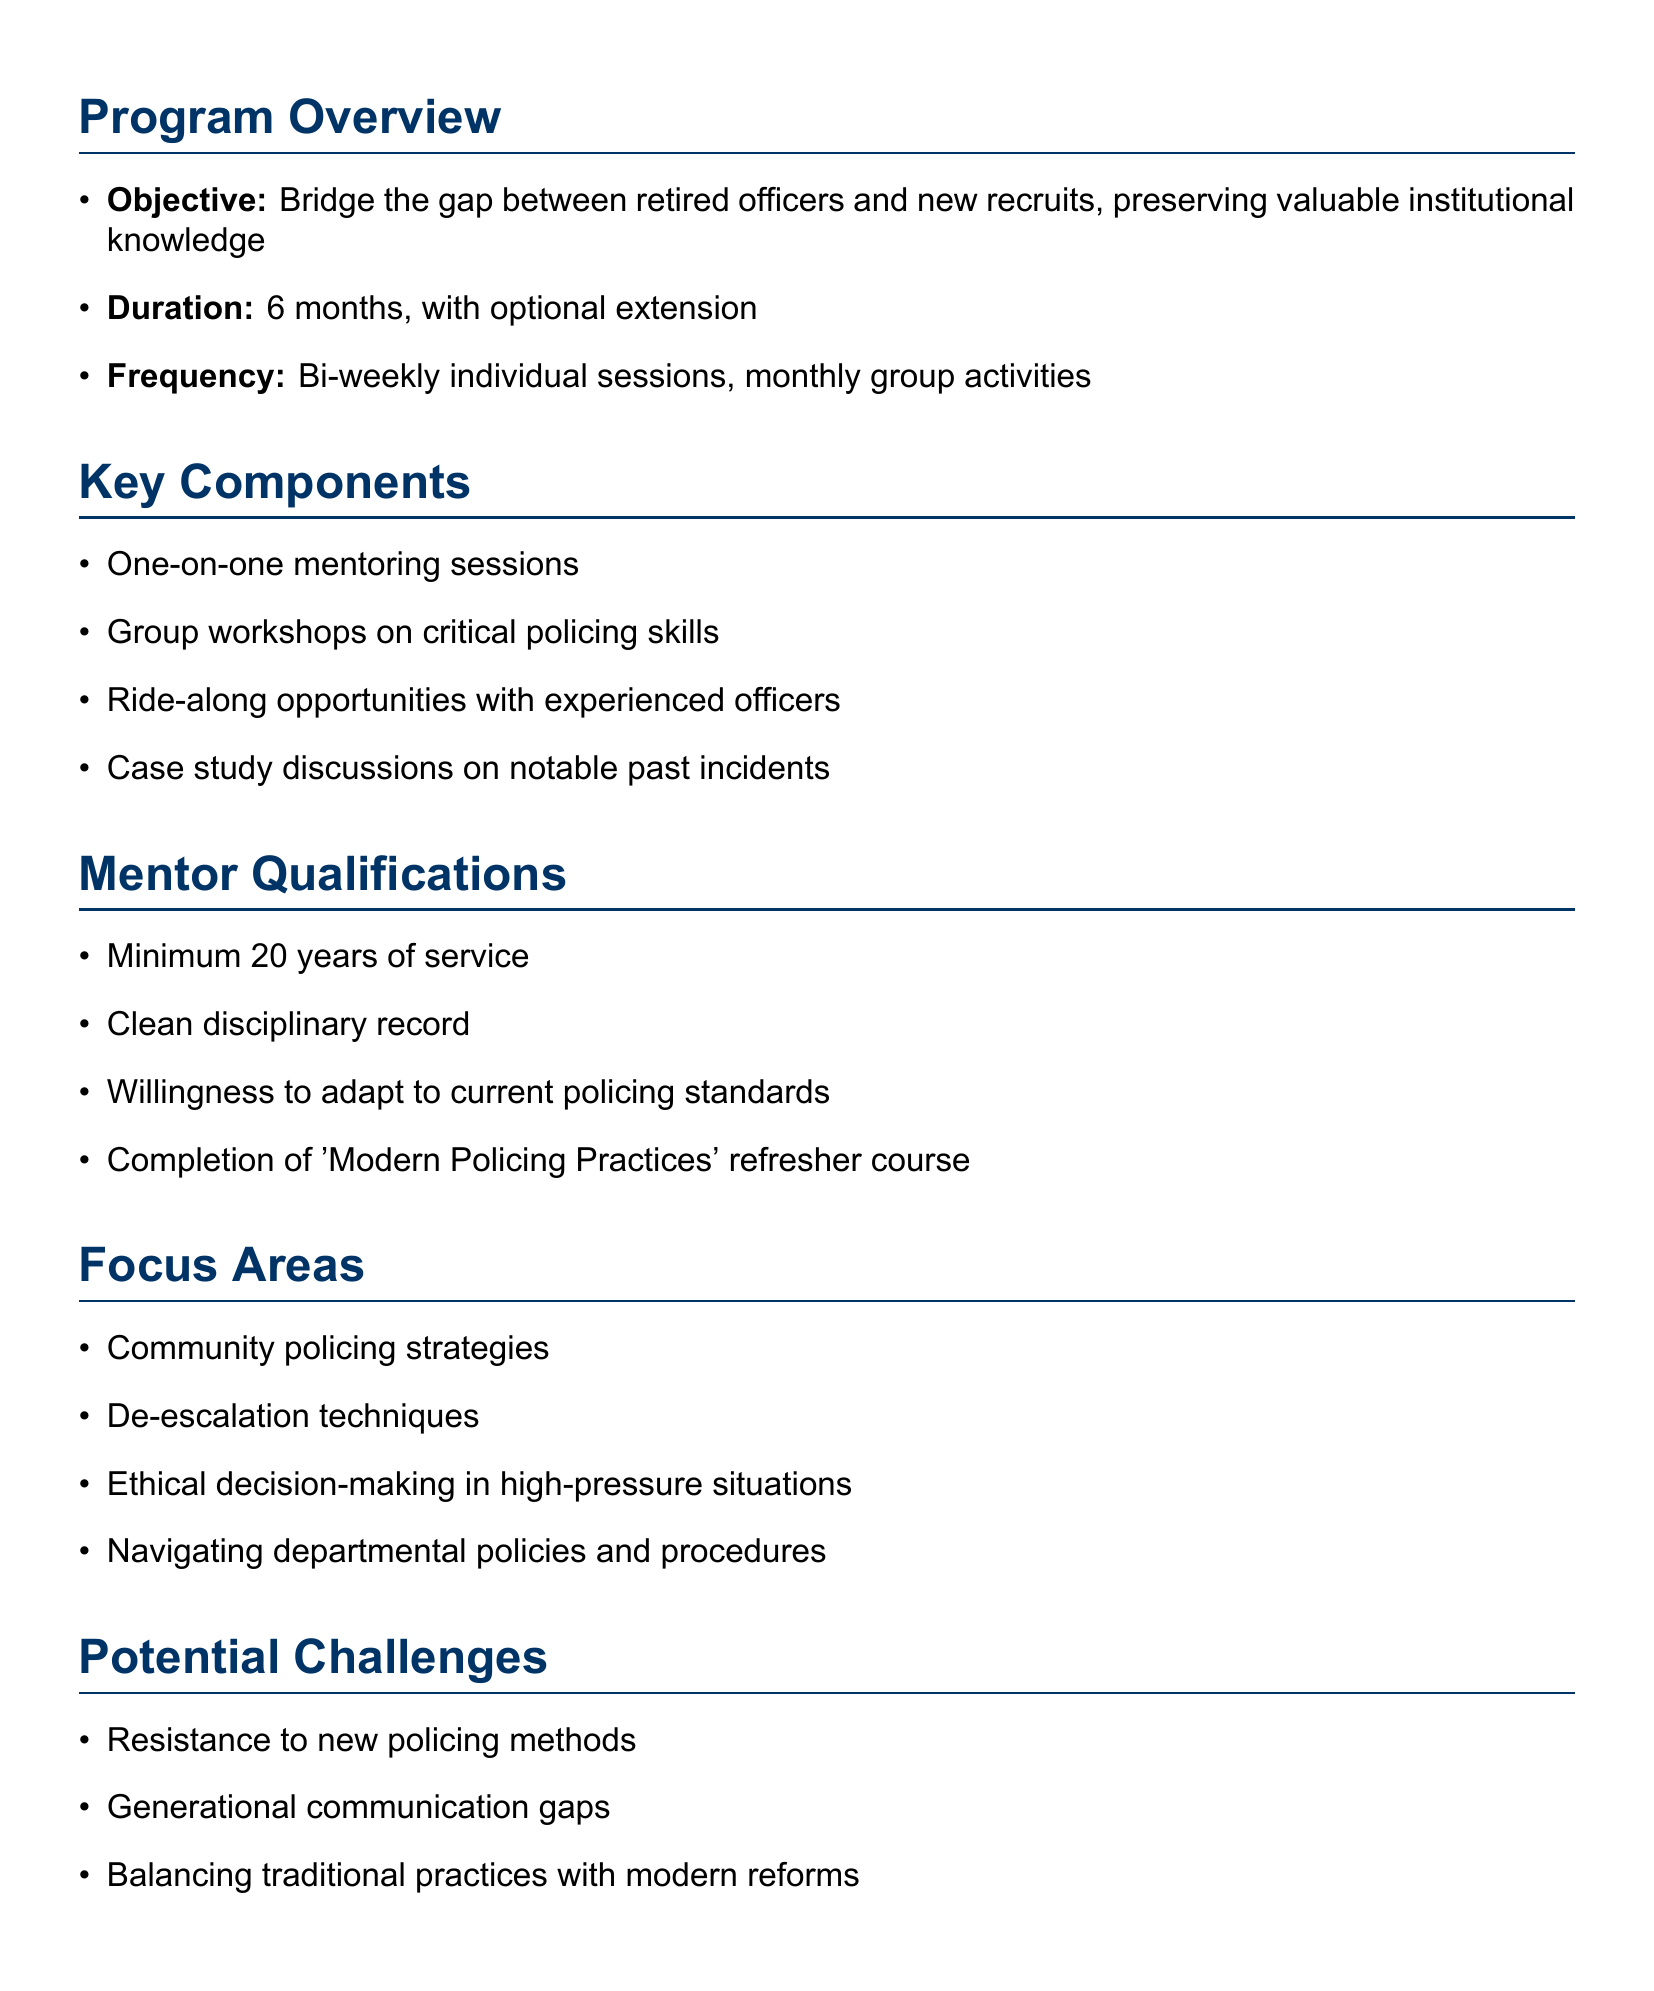What is the title of the program? The title of the program is mentioned at the beginning of the document.
Answer: Experience Exchange Program (EEP) What is the duration of the program? The document specifies the time frame for the program duration.
Answer: 6 months, with optional extension How often will individual sessions be held? The frequency of the sessions is detailed in the program outline.
Answer: Bi-weekly What is a key focus area of the program? The document lists several focus areas; this asks for one of them.
Answer: Community policing strategies What is a potential challenge mentioned in the document? The document includes potential challenges faced by the program.
Answer: Resistance to new policing methods How many years of service are required for mentors? This question addresses the criteria for mentor qualifications outlined in the document.
Answer: Minimum 20 years of service What is the expected outcome regarding recruitment? One of the outcomes of the program is referenced, relating to new recruits.
Answer: Improved retention rates for new recruits Who oversees the program? The oversight structure of the program is outlined in the document.
Answer: Joint committee of active duty supervisors and retired officer representatives What method is used for program evaluation? The document states the method of evaluation for the program.
Answer: Quarterly progress reports and feedback surveys from both mentors and mentees 